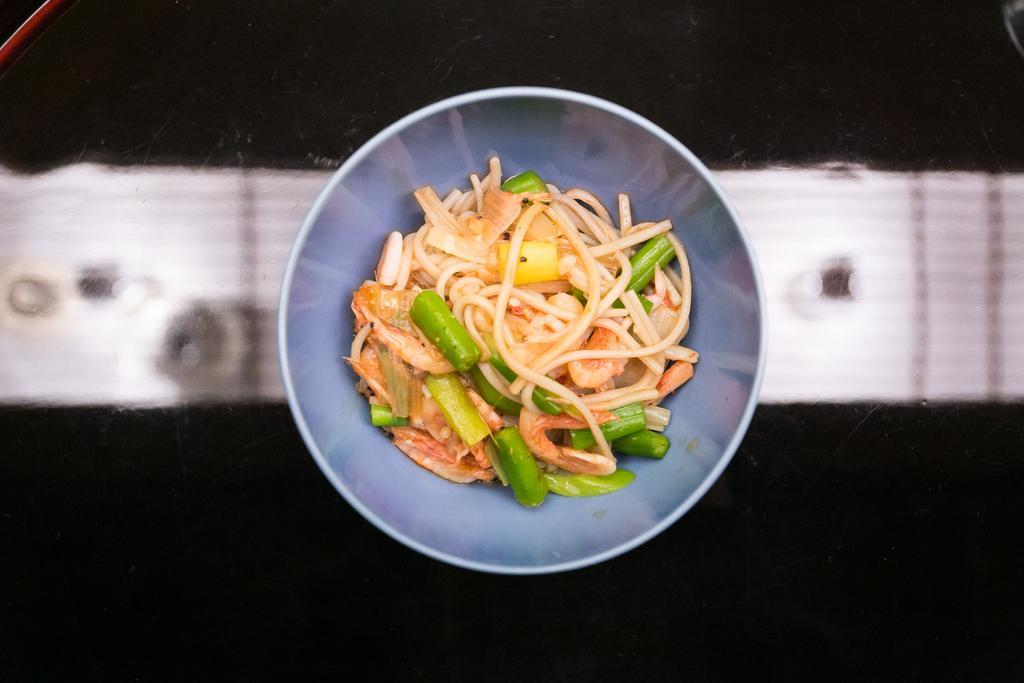In one or two sentences, can you explain what this image depicts? In this image we can see a food item called noodles which is in a bowl which is of blue color is on the surface. 